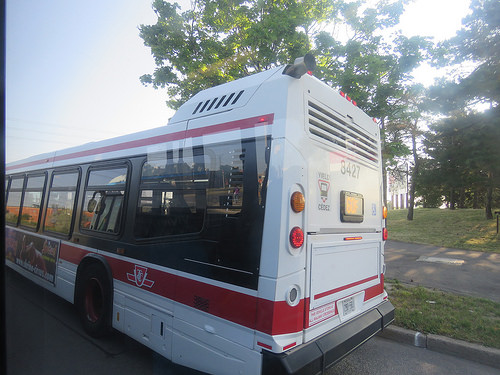<image>
Can you confirm if the bus is on the road? Yes. Looking at the image, I can see the bus is positioned on top of the road, with the road providing support. 